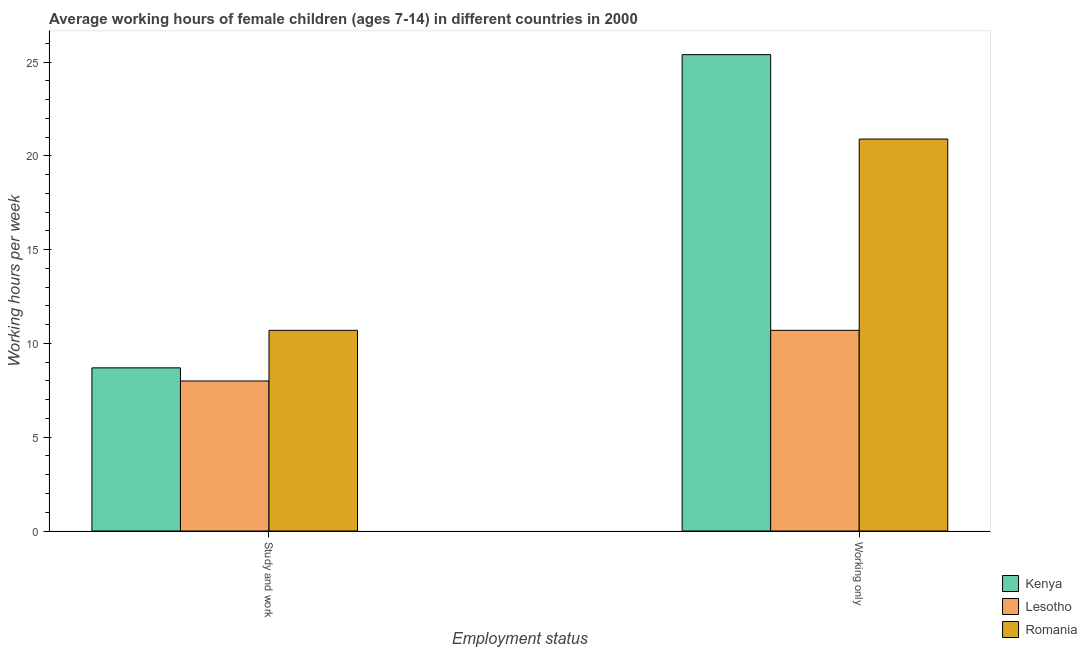Are the number of bars per tick equal to the number of legend labels?
Make the answer very short. Yes. What is the label of the 2nd group of bars from the left?
Give a very brief answer. Working only. What is the average working hour of children involved in only work in Romania?
Provide a succinct answer. 20.9. Across all countries, what is the maximum average working hour of children involved in only work?
Ensure brevity in your answer.  25.4. Across all countries, what is the minimum average working hour of children involved in study and work?
Offer a terse response. 8. In which country was the average working hour of children involved in study and work maximum?
Provide a succinct answer. Romania. In which country was the average working hour of children involved in only work minimum?
Give a very brief answer. Lesotho. What is the total average working hour of children involved in only work in the graph?
Your answer should be compact. 57. What is the difference between the average working hour of children involved in study and work in Romania and that in Kenya?
Your response must be concise. 2. What is the difference between the average working hour of children involved in only work in Kenya and the average working hour of children involved in study and work in Lesotho?
Provide a succinct answer. 17.4. What is the average average working hour of children involved in study and work per country?
Your answer should be very brief. 9.13. What is the difference between the average working hour of children involved in only work and average working hour of children involved in study and work in Kenya?
Give a very brief answer. 16.7. In how many countries, is the average working hour of children involved in only work greater than 12 hours?
Ensure brevity in your answer.  2. What is the ratio of the average working hour of children involved in study and work in Lesotho to that in Kenya?
Your answer should be compact. 0.92. Is the average working hour of children involved in study and work in Kenya less than that in Lesotho?
Offer a terse response. No. In how many countries, is the average working hour of children involved in study and work greater than the average average working hour of children involved in study and work taken over all countries?
Your response must be concise. 1. What does the 3rd bar from the left in Study and work represents?
Keep it short and to the point. Romania. What does the 3rd bar from the right in Working only represents?
Offer a terse response. Kenya. How many bars are there?
Make the answer very short. 6. Does the graph contain any zero values?
Offer a very short reply. No. How many legend labels are there?
Provide a succinct answer. 3. What is the title of the graph?
Offer a terse response. Average working hours of female children (ages 7-14) in different countries in 2000. What is the label or title of the X-axis?
Your answer should be compact. Employment status. What is the label or title of the Y-axis?
Ensure brevity in your answer.  Working hours per week. What is the Working hours per week in Kenya in Study and work?
Provide a short and direct response. 8.7. What is the Working hours per week in Kenya in Working only?
Ensure brevity in your answer.  25.4. What is the Working hours per week of Lesotho in Working only?
Your response must be concise. 10.7. What is the Working hours per week of Romania in Working only?
Your response must be concise. 20.9. Across all Employment status, what is the maximum Working hours per week in Kenya?
Keep it short and to the point. 25.4. Across all Employment status, what is the maximum Working hours per week of Lesotho?
Ensure brevity in your answer.  10.7. Across all Employment status, what is the maximum Working hours per week of Romania?
Offer a very short reply. 20.9. Across all Employment status, what is the minimum Working hours per week of Romania?
Provide a succinct answer. 10.7. What is the total Working hours per week in Kenya in the graph?
Provide a short and direct response. 34.1. What is the total Working hours per week in Lesotho in the graph?
Your response must be concise. 18.7. What is the total Working hours per week in Romania in the graph?
Provide a short and direct response. 31.6. What is the difference between the Working hours per week in Kenya in Study and work and that in Working only?
Offer a terse response. -16.7. What is the difference between the Working hours per week in Lesotho in Study and work and that in Working only?
Your answer should be compact. -2.7. What is the difference between the Working hours per week in Kenya in Study and work and the Working hours per week in Lesotho in Working only?
Provide a short and direct response. -2. What is the difference between the Working hours per week of Lesotho in Study and work and the Working hours per week of Romania in Working only?
Provide a succinct answer. -12.9. What is the average Working hours per week in Kenya per Employment status?
Give a very brief answer. 17.05. What is the average Working hours per week in Lesotho per Employment status?
Your response must be concise. 9.35. What is the average Working hours per week of Romania per Employment status?
Your answer should be very brief. 15.8. What is the difference between the Working hours per week in Kenya and Working hours per week in Lesotho in Study and work?
Ensure brevity in your answer.  0.7. What is the difference between the Working hours per week in Lesotho and Working hours per week in Romania in Study and work?
Make the answer very short. -2.7. What is the difference between the Working hours per week in Kenya and Working hours per week in Lesotho in Working only?
Offer a terse response. 14.7. What is the difference between the Working hours per week in Kenya and Working hours per week in Romania in Working only?
Offer a terse response. 4.5. What is the ratio of the Working hours per week of Kenya in Study and work to that in Working only?
Offer a very short reply. 0.34. What is the ratio of the Working hours per week in Lesotho in Study and work to that in Working only?
Your answer should be compact. 0.75. What is the ratio of the Working hours per week of Romania in Study and work to that in Working only?
Offer a very short reply. 0.51. What is the difference between the highest and the second highest Working hours per week in Lesotho?
Make the answer very short. 2.7. What is the difference between the highest and the second highest Working hours per week of Romania?
Provide a succinct answer. 10.2. What is the difference between the highest and the lowest Working hours per week of Lesotho?
Keep it short and to the point. 2.7. 